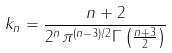Convert formula to latex. <formula><loc_0><loc_0><loc_500><loc_500>k _ { n } = \frac { n + 2 } { 2 ^ { n } \pi ^ { ( n - 3 ) / 2 } \Gamma \left ( \frac { n + 3 } { 2 } \right ) }</formula> 